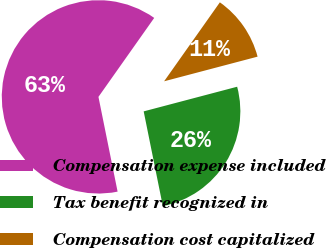<chart> <loc_0><loc_0><loc_500><loc_500><pie_chart><fcel>Compensation expense included<fcel>Tax benefit recognized in<fcel>Compensation cost capitalized<nl><fcel>62.96%<fcel>25.93%<fcel>11.11%<nl></chart> 